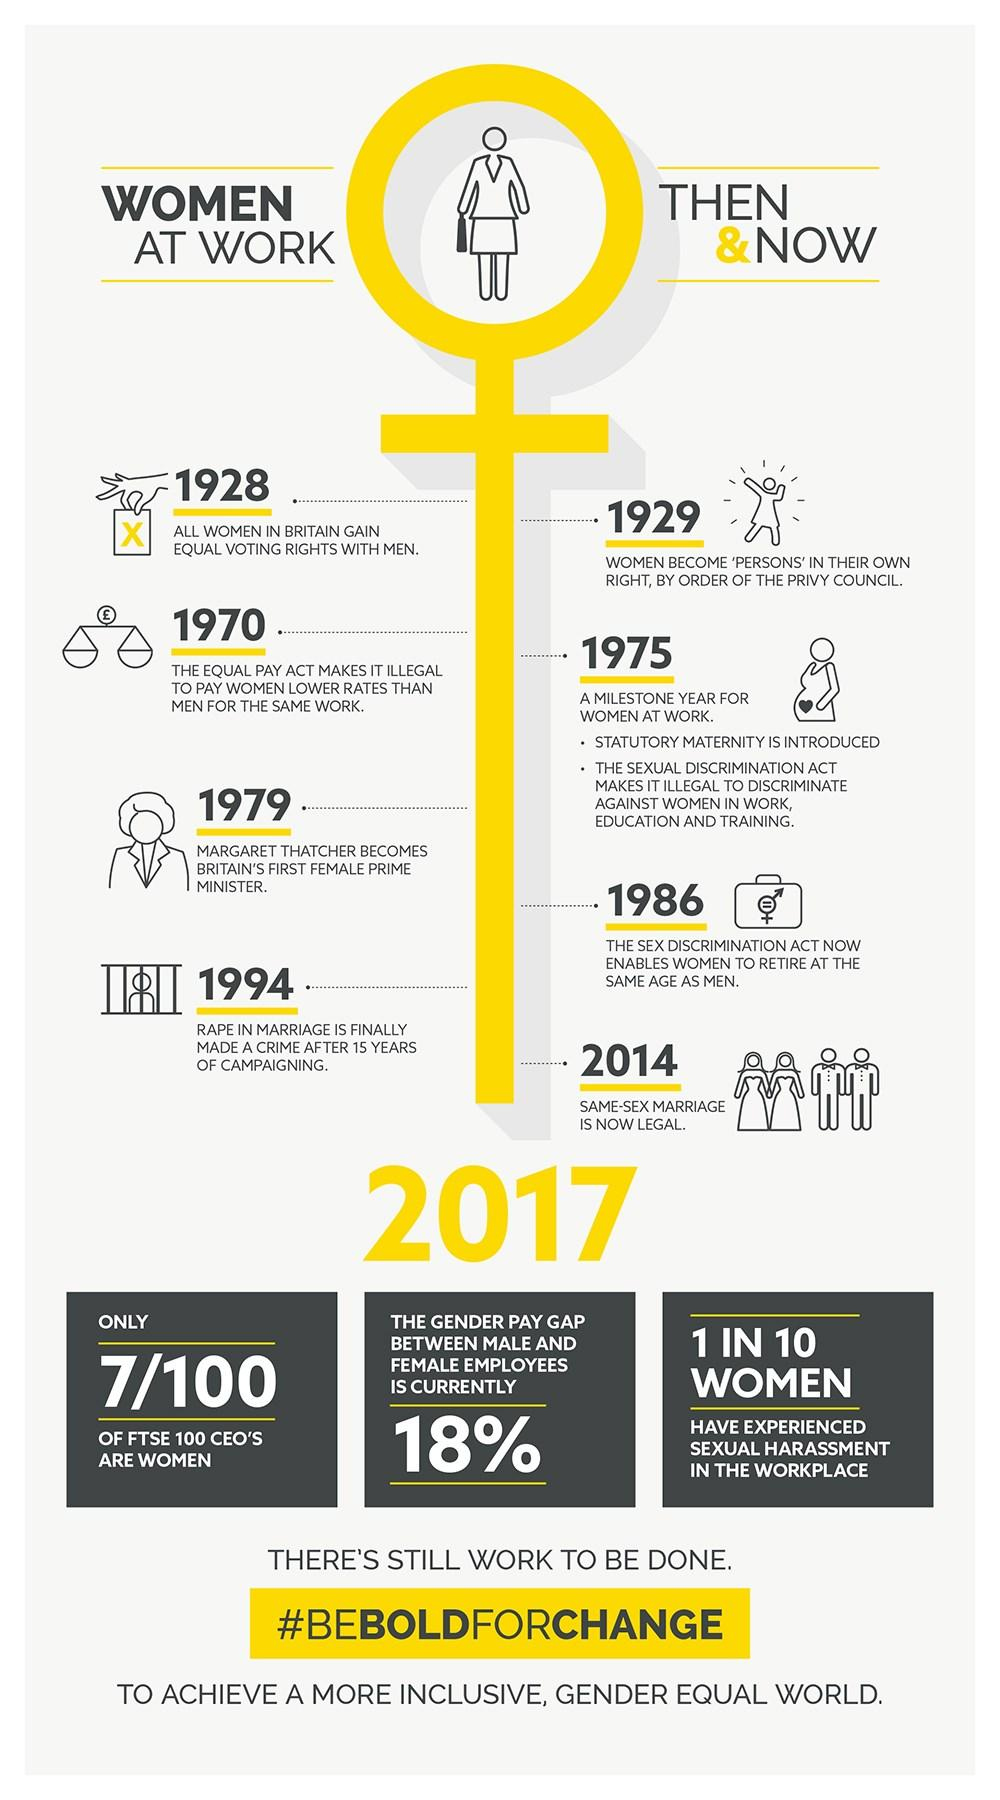Point out several critical features in this image. Seven of the CEOs of FTSE 100 companies are women. In 1994, rape in marriage was finally made a crime. As of 1986, women were allowed to retire at the same age as men. Prior to 1928, only men had the exclusive right to vote. In 1975, the Sexual Discrimination Act was enacted, making it illegal to discriminate against women in the areas of work, education, and training. 